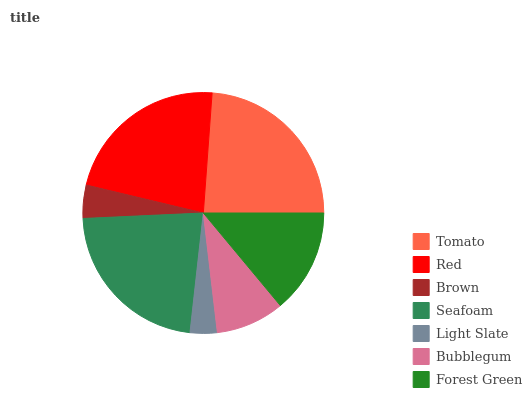Is Light Slate the minimum?
Answer yes or no. Yes. Is Tomato the maximum?
Answer yes or no. Yes. Is Red the minimum?
Answer yes or no. No. Is Red the maximum?
Answer yes or no. No. Is Tomato greater than Red?
Answer yes or no. Yes. Is Red less than Tomato?
Answer yes or no. Yes. Is Red greater than Tomato?
Answer yes or no. No. Is Tomato less than Red?
Answer yes or no. No. Is Forest Green the high median?
Answer yes or no. Yes. Is Forest Green the low median?
Answer yes or no. Yes. Is Red the high median?
Answer yes or no. No. Is Bubblegum the low median?
Answer yes or no. No. 